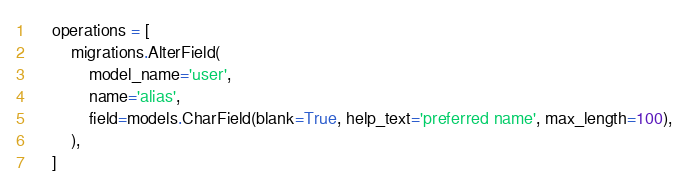Convert code to text. <code><loc_0><loc_0><loc_500><loc_500><_Python_>    operations = [
        migrations.AlterField(
            model_name='user',
            name='alias',
            field=models.CharField(blank=True, help_text='preferred name', max_length=100),
        ),
    ]
</code> 